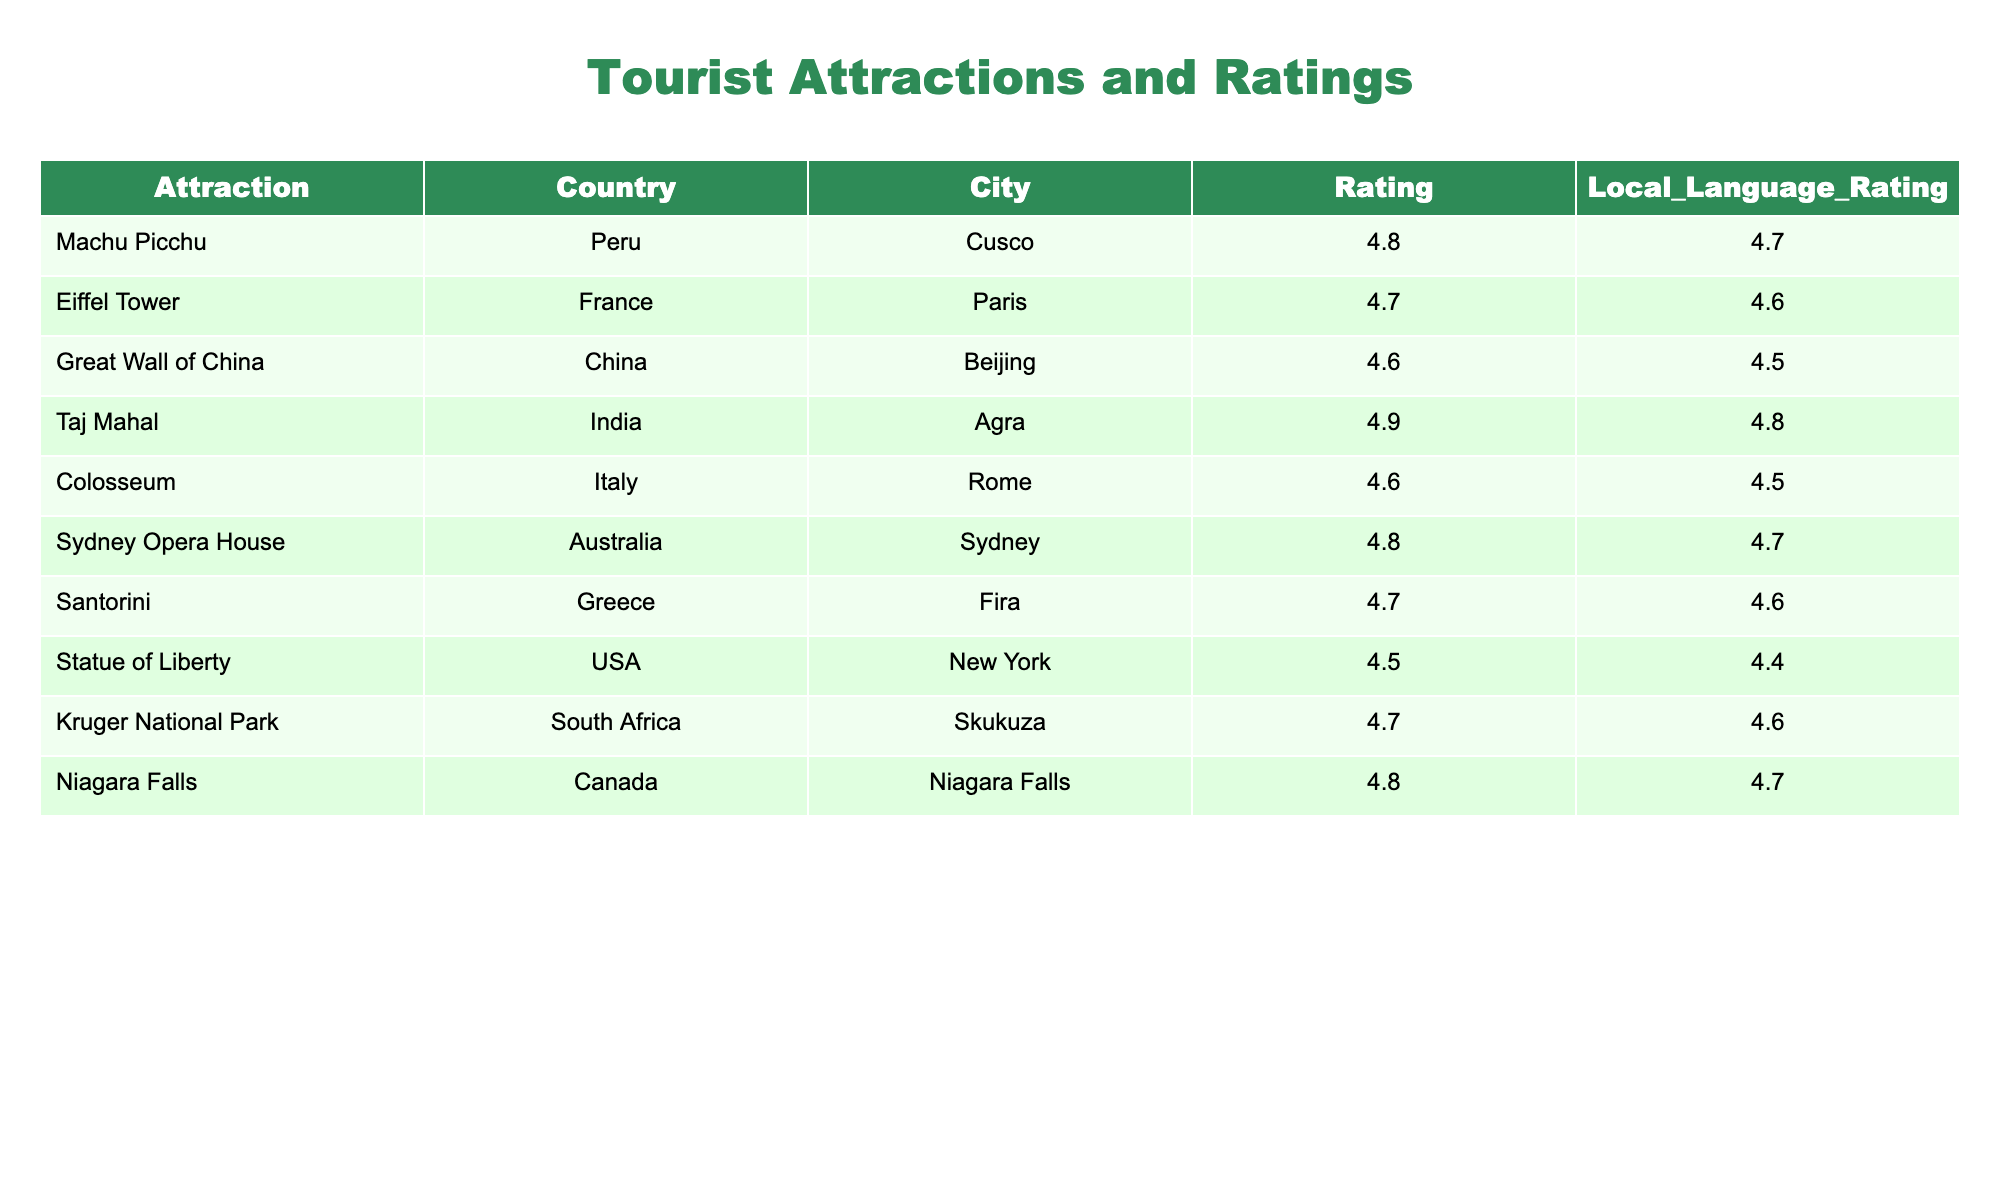What is the highest rating among the attractions? By looking through the "Rating" column, I can see that the highest value present is 4.9, which corresponds to the Taj Mahal in Agra, India.
Answer: 4.9 Which attraction has the lowest rating? Examining the "Rating" column reveals that the Statute of Liberty in New York, USA has the lowest rating at 4.5.
Answer: 4.5 What is the average rating of attractions in Europe? The attractions in Europe are the Eiffel Tower, Colosseum, and Santorini, with ratings of 4.7, 4.6, and 4.7 respectively. To find the average, I sum these ratings: (4.7 + 4.6 + 4.7) = 14.0, and then divide by the number of attractions (3), yielding an average of 14.0 / 3 = 4.67.
Answer: 4.67 Is Machu Picchu rated higher than the Statue of Liberty? Comparing the ratings from both attractions, Machu Picchu has a rating of 4.8, while the Statue of Liberty has a rating of 4.5. Since 4.8 is greater than 4.5, Machu Picchu is indeed rated higher.
Answer: Yes Which attraction has a local language rating of 4.7? Looking through the "Local_Language_Rating" column, I find that Machu Picchu (Peru), Sydney Opera House (Australia), and Niagara Falls (Canada) all have a local language rating of 4.7.
Answer: Machu Picchu, Sydney Opera House, Niagara Falls What is the difference between the highest and lowest local language ratings? The highest local language rating is 4.8 for the Taj Mahal, and the lowest is 4.4 for the Statue of Liberty. The difference is calculated as 4.8 - 4.4 = 0.4.
Answer: 0.4 Are there any attractions that have the same rating? Yes, by reviewing the "Rating" column, I see that the Eiffel Tower (4.7) and Santorini (4.7) have the same rating.
Answer: Yes What is the total rating score of all attractions in Asia? The attractions in Asia include the Great Wall of China (4.6), Taj Mahal (4.9), resulting in a total rating of 4.6 + 4.9 = 9.5.
Answer: 9.5 Which city has an attraction with a local language rating of 4.6? Checking the "Local_Language_Rating" column, I find that attractions in Paris (Eiffel Tower), Fira (Santorini), and Skukuza (Kruger National Park) have a rating of 4.6.
Answer: Paris, Fira, Skukuza 